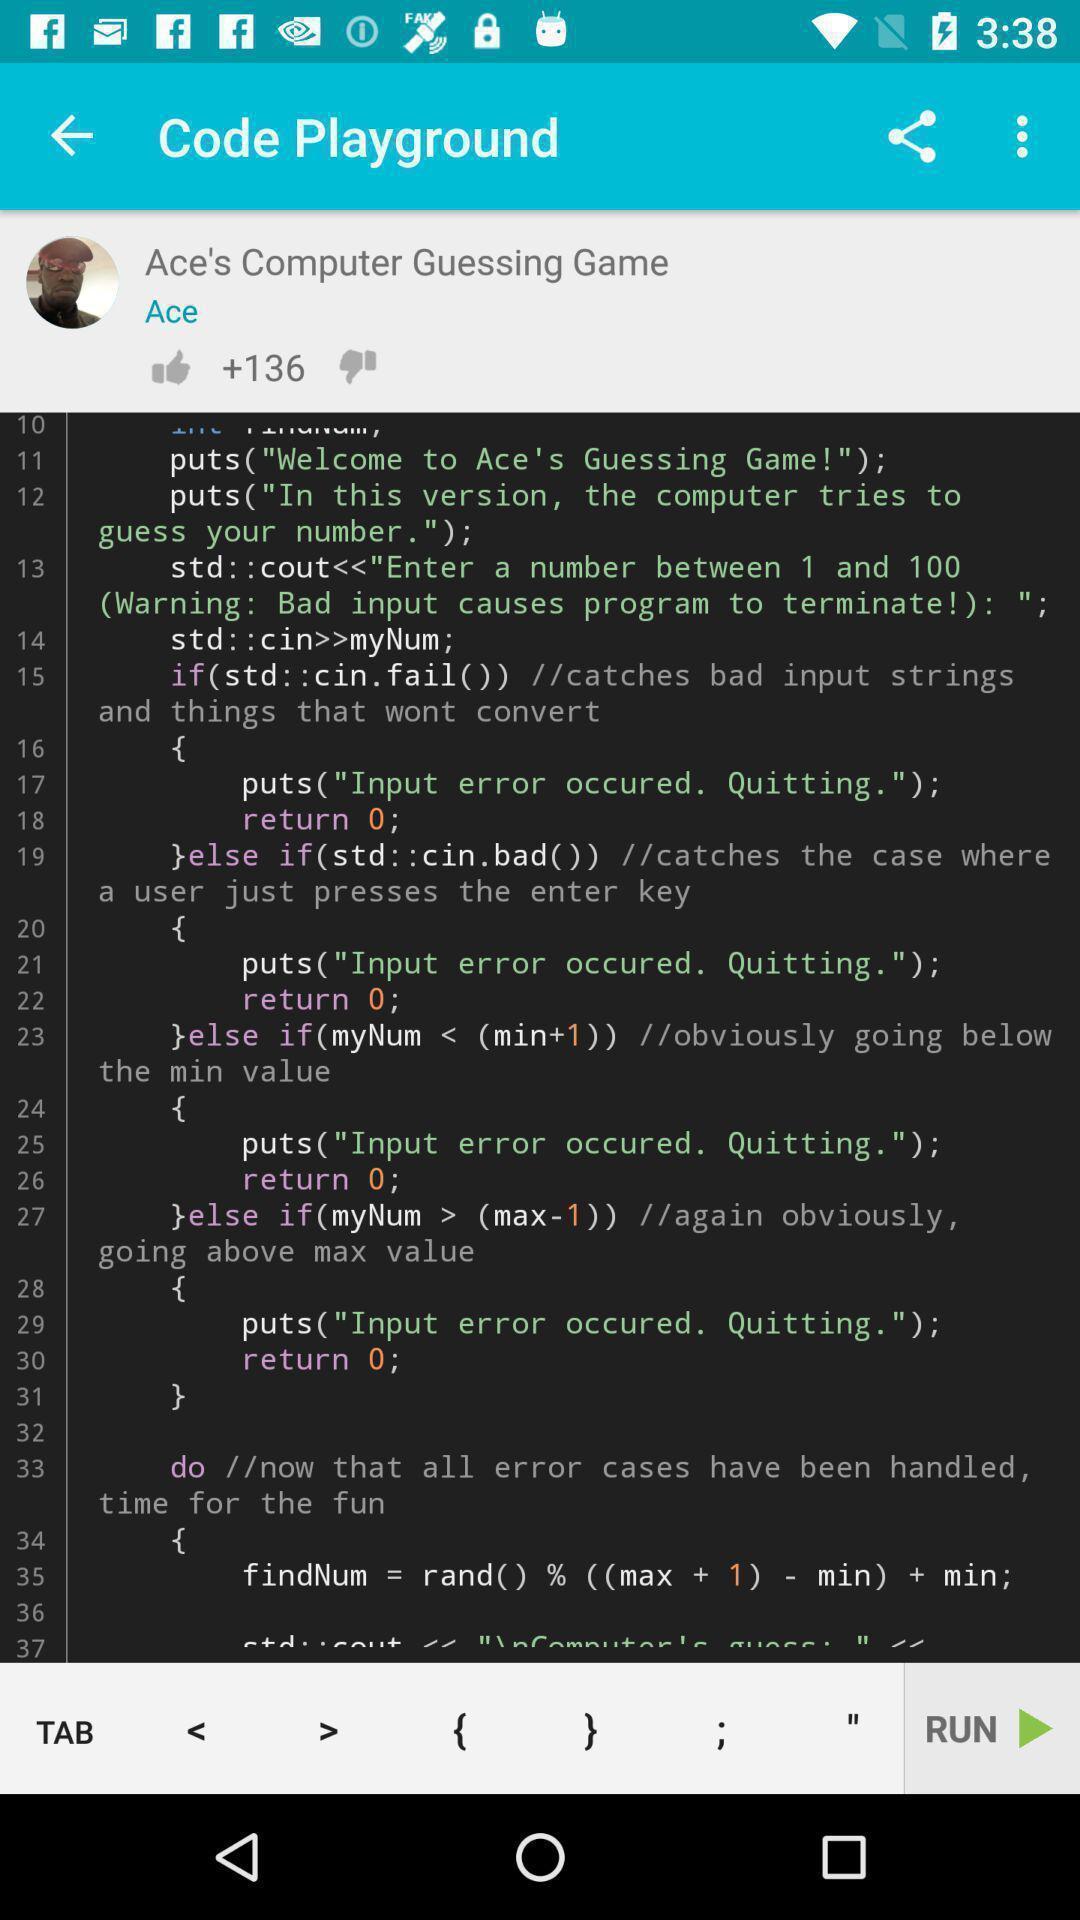Explain what's happening in this screen capture. Screen displaying multiple controls in a learning application. 